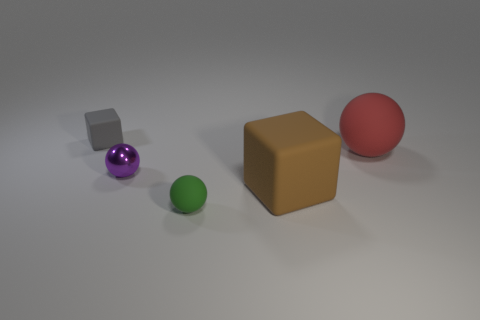What number of other things are the same size as the brown thing?
Your response must be concise. 1. What is the small purple thing made of?
Make the answer very short. Metal. Is the material of the large brown cube the same as the red ball?
Make the answer very short. Yes. How many rubber objects are either red objects or tiny green spheres?
Offer a very short reply. 2. What shape is the object left of the tiny purple sphere?
Offer a terse response. Cube. What size is the gray block that is made of the same material as the big brown block?
Your answer should be very brief. Small. What shape is the matte object that is both in front of the tiny purple ball and to the left of the big cube?
Your answer should be very brief. Sphere. There is a matte cube that is behind the large red rubber thing; does it have the same color as the tiny metallic sphere?
Ensure brevity in your answer.  No. There is a gray thing on the left side of the tiny green matte ball; does it have the same shape as the tiny matte thing that is in front of the big rubber block?
Offer a terse response. No. What is the size of the matte sphere left of the big matte sphere?
Provide a short and direct response. Small. 